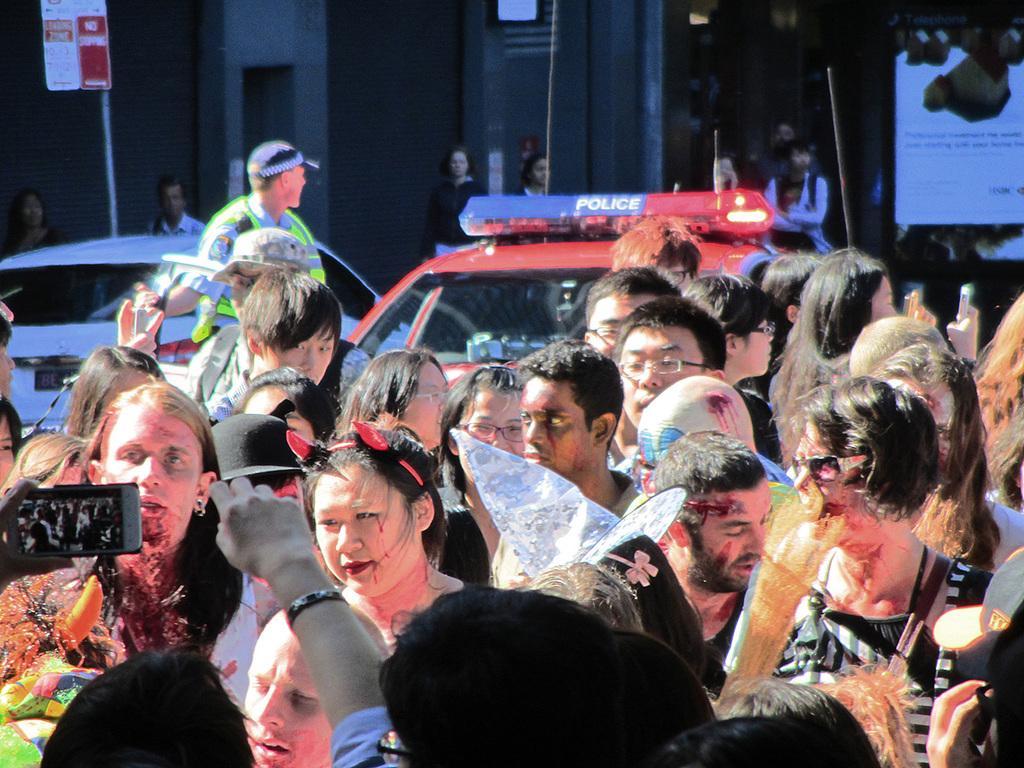Can you describe this image briefly? This picture is clicked outside the city. At the bottom of the picture, we see people standing on the road. Behind there are two cars moving on the road. The police officer is standing beside the cars. In the background, we see people standing. Behind them, there are buildings. On the right side, we see a white board with some text written on it. In the left top of the picture, we see a board in red and white color with some text written on it. 